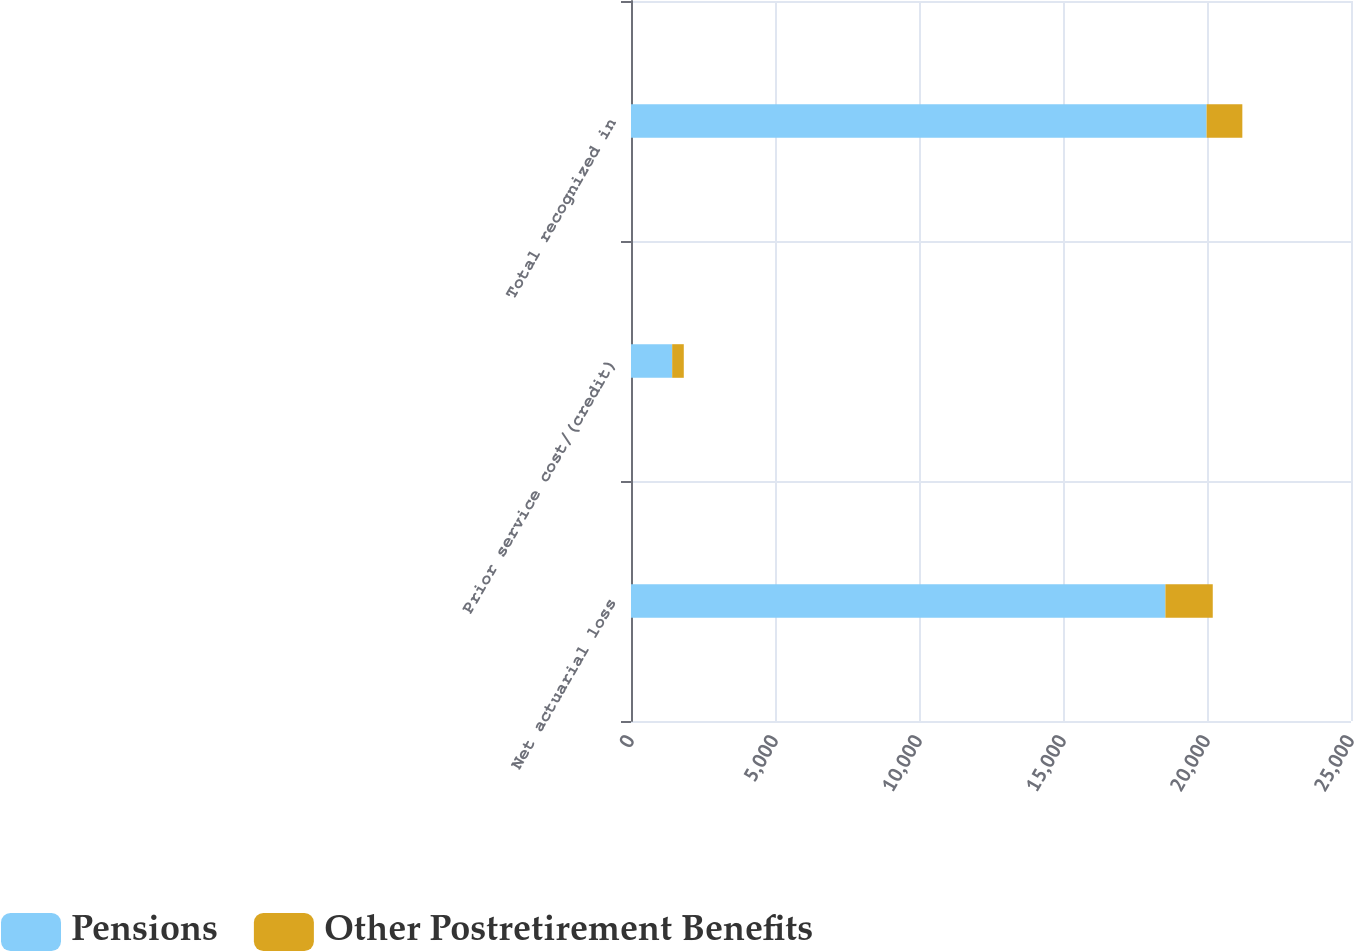Convert chart to OTSL. <chart><loc_0><loc_0><loc_500><loc_500><stacked_bar_chart><ecel><fcel>Net actuarial loss<fcel>Prior service cost/(credit)<fcel>Total recognized in<nl><fcel>Pensions<fcel>18556<fcel>1430<fcel>19986<nl><fcel>Other Postretirement Benefits<fcel>1644<fcel>403<fcel>1241<nl></chart> 